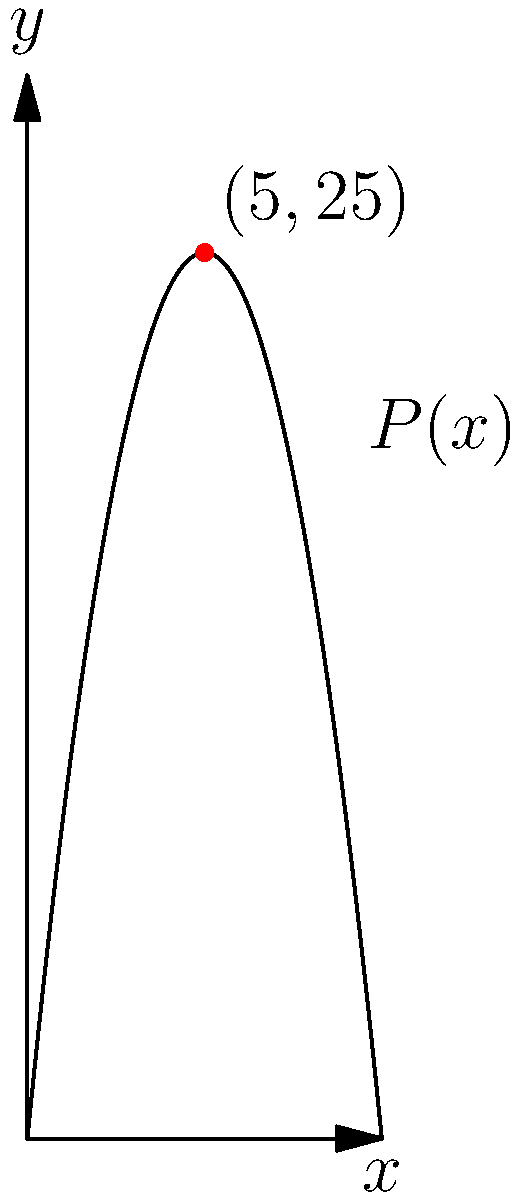As a social entrepreneur, you've developed a product that aims to maximize both profit and social impact. Your profit function is given by $P(x) = -x^2 + 10x$, where $x$ represents the number of units produced (in thousands) and $P(x)$ represents the profit in thousands of dollars. Using the graph provided, determine the maximum profit and the corresponding number of units that should be produced to achieve this profit. To solve this optimization problem, we'll follow these steps:

1) The graph shows a parabola opening downwards, which is consistent with the quadratic function $P(x) = -x^2 + 10x$.

2) The maximum point of a parabola occurs at its vertex. From the graph, we can see that the vertex is clearly marked at the point (5, 25).

3) This means that:
   - The x-coordinate of the vertex is 5, so $x = 5$ (thousand units)
   - The y-coordinate of the vertex is 25, so $P(x) = 25$ (thousand dollars)

4) To verify algebraically:
   $P(x) = -x^2 + 10x$
   The vertex of a parabola $y = ax^2 + bx + c$ occurs at $x = -\frac{b}{2a}$
   Here, $a = -1$ and $b = 10$, so $x = -\frac{10}{2(-1)} = 5$

5) Plugging $x = 5$ into the original function:
   $P(5) = -(5)^2 + 10(5) = -25 + 50 = 25$

Therefore, the maximum profit is $25,000 when 5,000 units are produced.
Answer: $25,000 at 5,000 units 